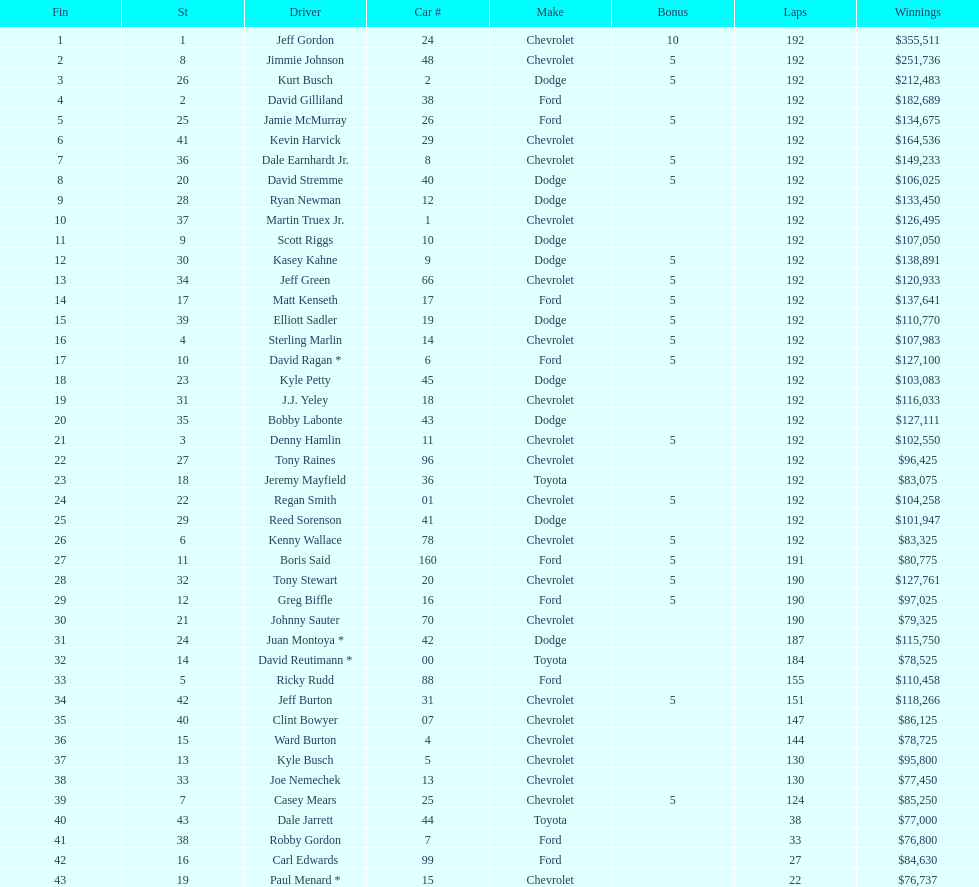How many drivers earned no bonus for this race? 23. 